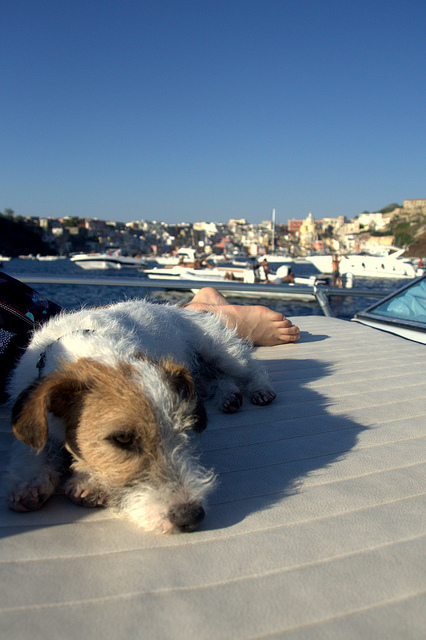<image>Are there shoes on the person's feet? No, there are no shoes on the person's feet. Are there shoes on the person's feet? Yes, there are no shoes on the person's feet. 